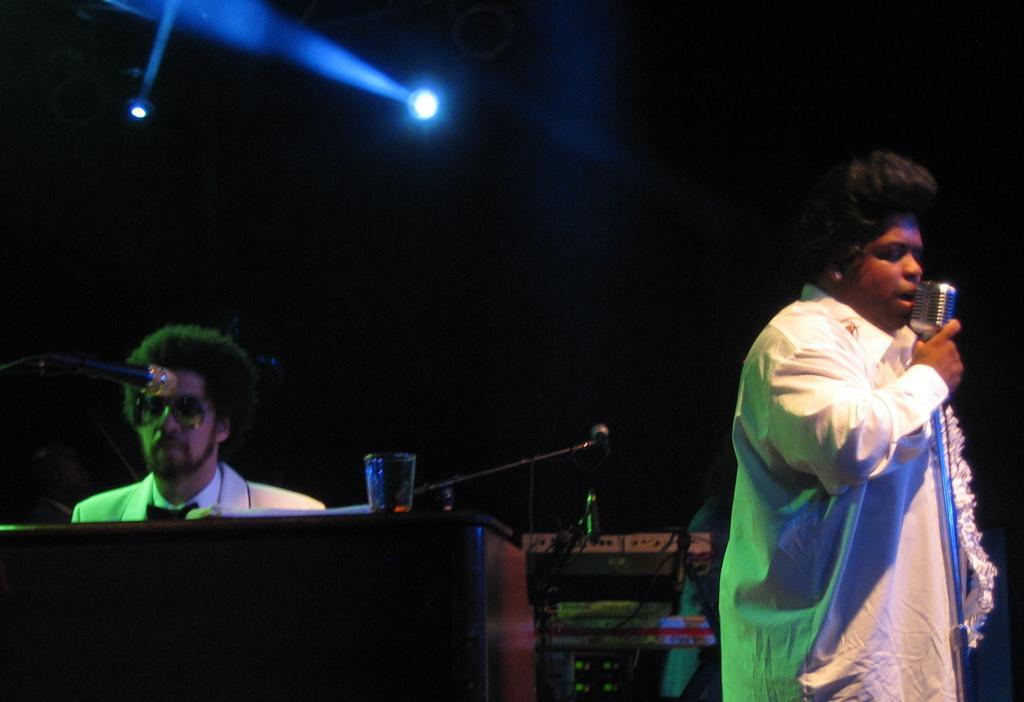Describe this image in one or two sentences. In this image there is a person on the right side who is wearing the white dress is holding the mic. On the left side there is another person who is sitting. In front of him there is table on which there is a glass and a mic. At the top there are lights. In the background there are wires and keyboard. 